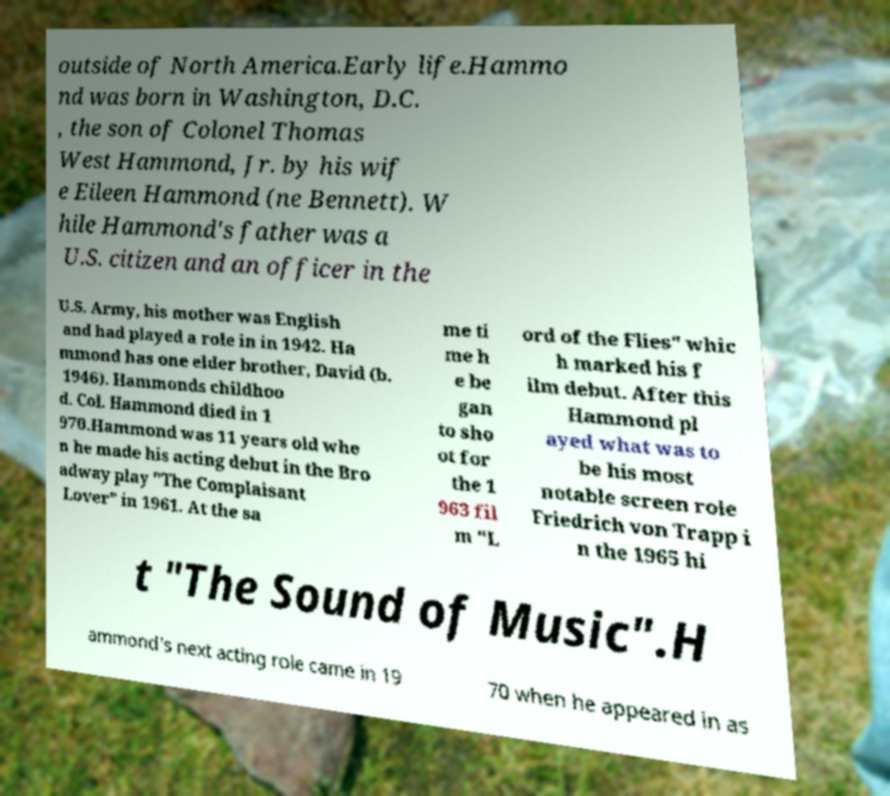I need the written content from this picture converted into text. Can you do that? outside of North America.Early life.Hammo nd was born in Washington, D.C. , the son of Colonel Thomas West Hammond, Jr. by his wif e Eileen Hammond (ne Bennett). W hile Hammond's father was a U.S. citizen and an officer in the U.S. Army, his mother was English and had played a role in in 1942. Ha mmond has one elder brother, David (b. 1946). Hammonds childhoo d. Col. Hammond died in 1 970.Hammond was 11 years old whe n he made his acting debut in the Bro adway play "The Complaisant Lover" in 1961. At the sa me ti me h e be gan to sho ot for the 1 963 fil m "L ord of the Flies" whic h marked his f ilm debut. After this Hammond pl ayed what was to be his most notable screen role Friedrich von Trapp i n the 1965 hi t "The Sound of Music".H ammond's next acting role came in 19 70 when he appeared in as 